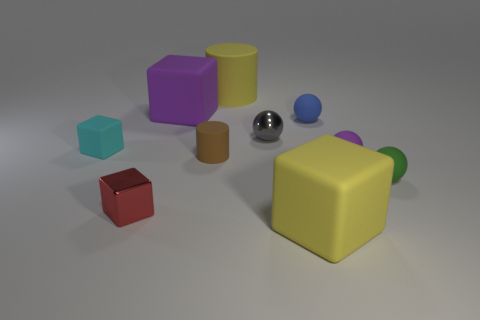Subtract all purple blocks. How many blocks are left? 3 Subtract all yellow spheres. Subtract all brown blocks. How many spheres are left? 4 Subtract all cylinders. How many objects are left? 8 Add 1 large brown objects. How many large brown objects exist? 1 Subtract 1 purple cubes. How many objects are left? 9 Subtract all small blue objects. Subtract all small cylinders. How many objects are left? 8 Add 6 tiny blue objects. How many tiny blue objects are left? 7 